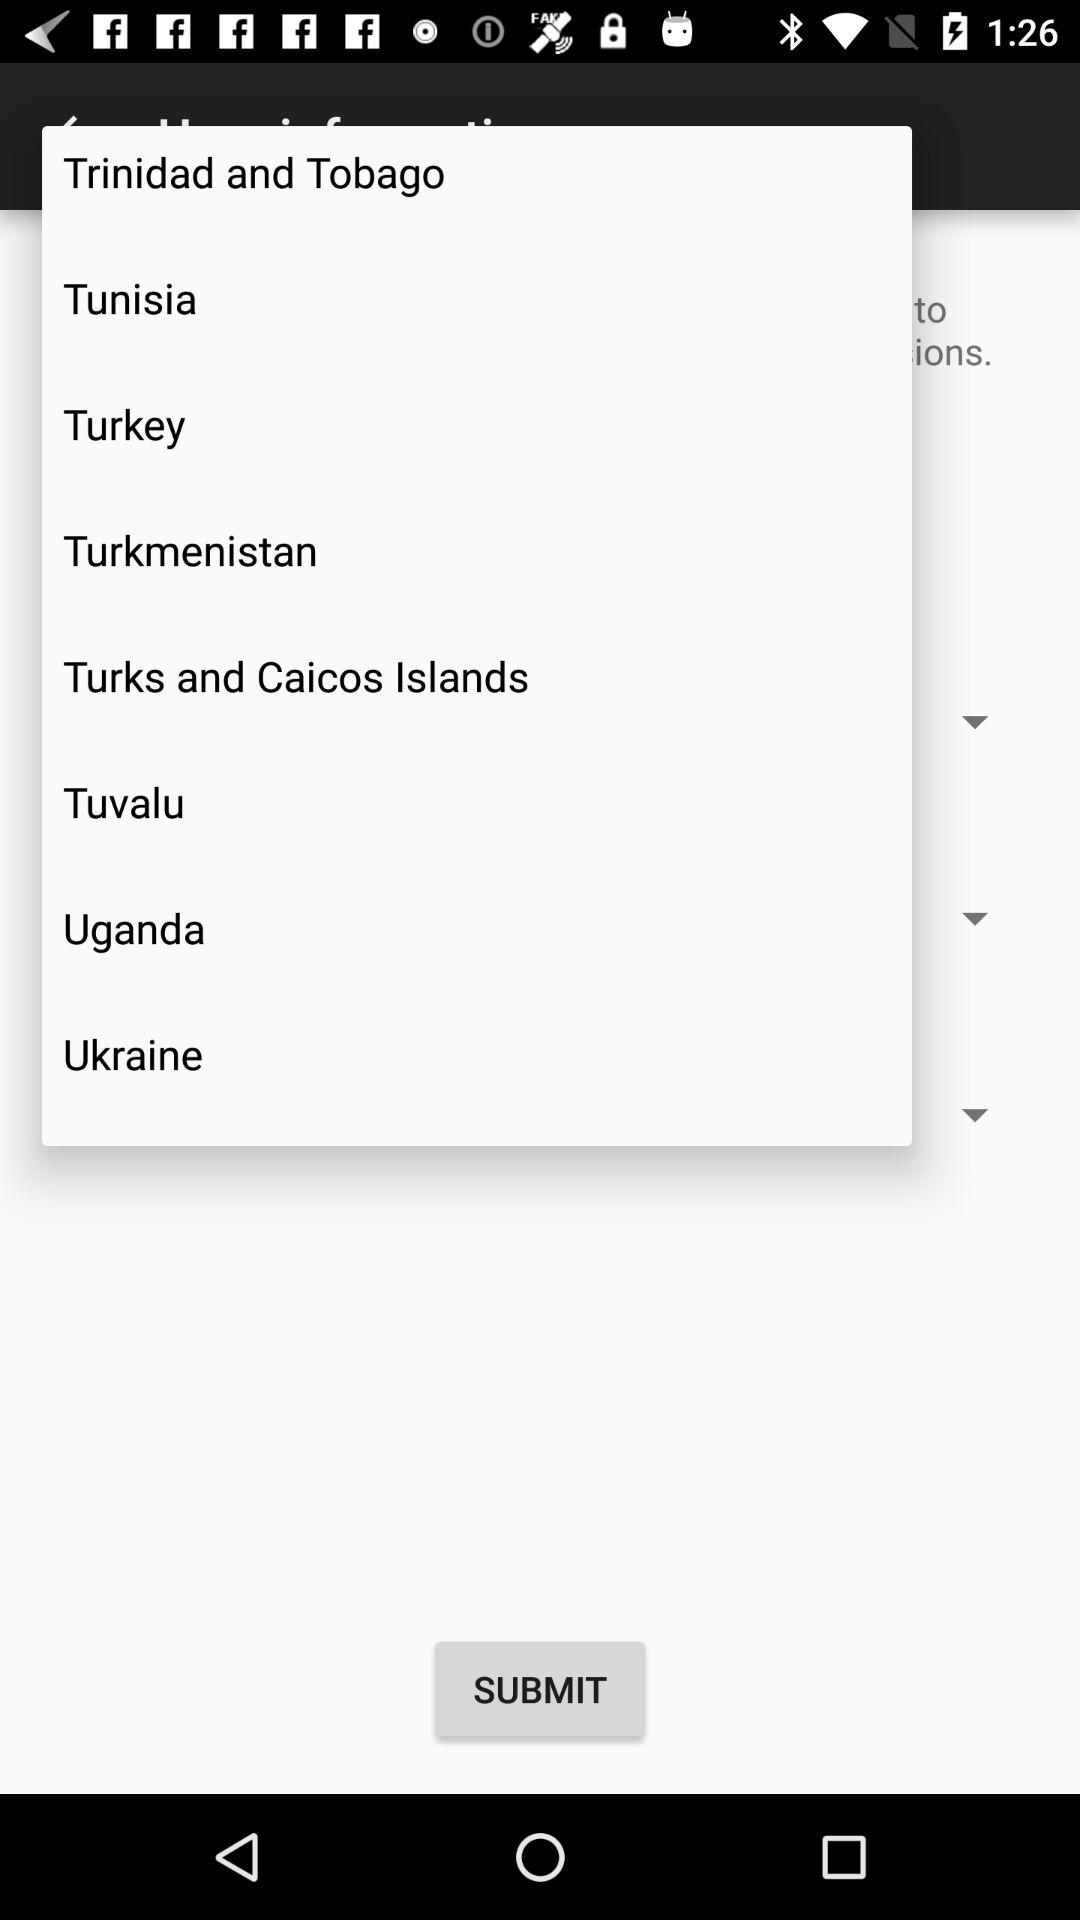What are the names of the countries? The names of the countries are Trinidad and Tobago, Tunisia, Turkey, Turkmenistan, Uganda and Ukraine. 